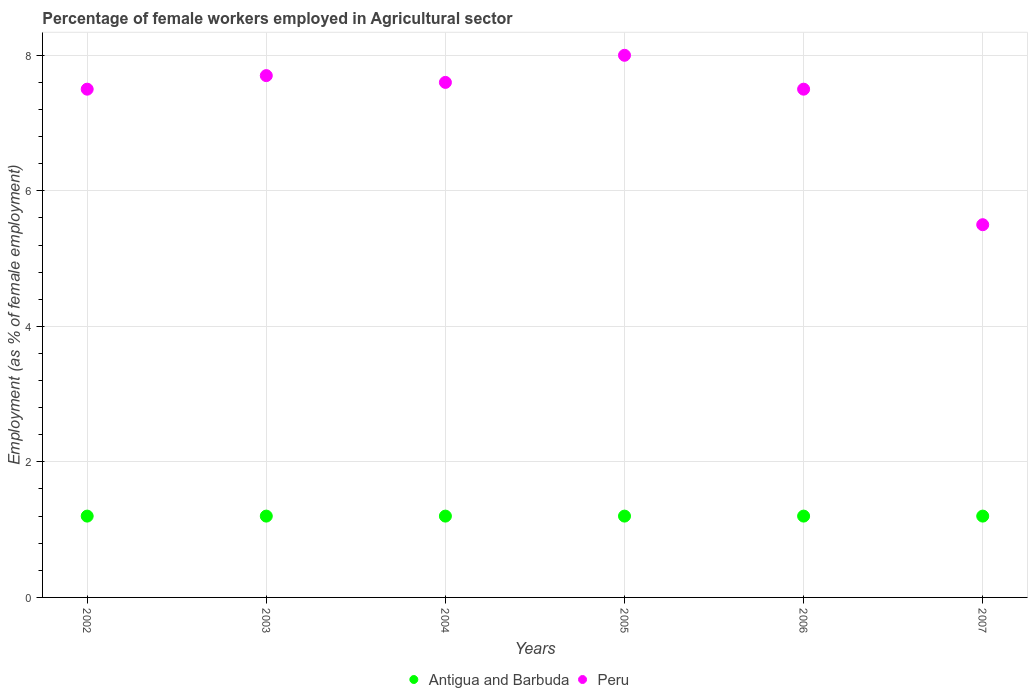How many different coloured dotlines are there?
Your answer should be very brief. 2. What is the percentage of females employed in Agricultural sector in Antigua and Barbuda in 2003?
Give a very brief answer. 1.2. Across all years, what is the maximum percentage of females employed in Agricultural sector in Antigua and Barbuda?
Ensure brevity in your answer.  1.2. In which year was the percentage of females employed in Agricultural sector in Peru minimum?
Offer a terse response. 2007. What is the total percentage of females employed in Agricultural sector in Peru in the graph?
Offer a very short reply. 43.8. What is the difference between the percentage of females employed in Agricultural sector in Antigua and Barbuda in 2002 and that in 2003?
Offer a terse response. 0. What is the difference between the percentage of females employed in Agricultural sector in Antigua and Barbuda in 2003 and the percentage of females employed in Agricultural sector in Peru in 2007?
Your response must be concise. -4.3. What is the average percentage of females employed in Agricultural sector in Peru per year?
Your answer should be very brief. 7.3. In the year 2003, what is the difference between the percentage of females employed in Agricultural sector in Antigua and Barbuda and percentage of females employed in Agricultural sector in Peru?
Ensure brevity in your answer.  -6.5. In how many years, is the percentage of females employed in Agricultural sector in Antigua and Barbuda greater than 6.4 %?
Make the answer very short. 0. What is the ratio of the percentage of females employed in Agricultural sector in Peru in 2005 to that in 2007?
Offer a terse response. 1.45. Is the percentage of females employed in Agricultural sector in Peru in 2003 less than that in 2004?
Offer a terse response. No. What is the difference between the highest and the second highest percentage of females employed in Agricultural sector in Peru?
Make the answer very short. 0.3. What is the difference between the highest and the lowest percentage of females employed in Agricultural sector in Antigua and Barbuda?
Keep it short and to the point. 0. In how many years, is the percentage of females employed in Agricultural sector in Peru greater than the average percentage of females employed in Agricultural sector in Peru taken over all years?
Provide a succinct answer. 5. Are the values on the major ticks of Y-axis written in scientific E-notation?
Offer a very short reply. No. Does the graph contain grids?
Offer a very short reply. Yes. How are the legend labels stacked?
Provide a succinct answer. Horizontal. What is the title of the graph?
Give a very brief answer. Percentage of female workers employed in Agricultural sector. Does "Marshall Islands" appear as one of the legend labels in the graph?
Provide a short and direct response. No. What is the label or title of the X-axis?
Keep it short and to the point. Years. What is the label or title of the Y-axis?
Provide a succinct answer. Employment (as % of female employment). What is the Employment (as % of female employment) of Antigua and Barbuda in 2002?
Ensure brevity in your answer.  1.2. What is the Employment (as % of female employment) in Peru in 2002?
Keep it short and to the point. 7.5. What is the Employment (as % of female employment) of Antigua and Barbuda in 2003?
Give a very brief answer. 1.2. What is the Employment (as % of female employment) of Peru in 2003?
Give a very brief answer. 7.7. What is the Employment (as % of female employment) in Antigua and Barbuda in 2004?
Ensure brevity in your answer.  1.2. What is the Employment (as % of female employment) of Peru in 2004?
Your response must be concise. 7.6. What is the Employment (as % of female employment) of Antigua and Barbuda in 2005?
Your answer should be very brief. 1.2. What is the Employment (as % of female employment) in Peru in 2005?
Give a very brief answer. 8. What is the Employment (as % of female employment) in Antigua and Barbuda in 2006?
Your answer should be very brief. 1.2. What is the Employment (as % of female employment) in Antigua and Barbuda in 2007?
Offer a terse response. 1.2. What is the Employment (as % of female employment) of Peru in 2007?
Make the answer very short. 5.5. Across all years, what is the maximum Employment (as % of female employment) in Antigua and Barbuda?
Offer a terse response. 1.2. Across all years, what is the maximum Employment (as % of female employment) in Peru?
Ensure brevity in your answer.  8. Across all years, what is the minimum Employment (as % of female employment) in Antigua and Barbuda?
Keep it short and to the point. 1.2. What is the total Employment (as % of female employment) of Peru in the graph?
Provide a succinct answer. 43.8. What is the difference between the Employment (as % of female employment) in Antigua and Barbuda in 2002 and that in 2003?
Your response must be concise. 0. What is the difference between the Employment (as % of female employment) of Peru in 2002 and that in 2003?
Provide a succinct answer. -0.2. What is the difference between the Employment (as % of female employment) in Antigua and Barbuda in 2002 and that in 2004?
Give a very brief answer. 0. What is the difference between the Employment (as % of female employment) of Peru in 2002 and that in 2004?
Keep it short and to the point. -0.1. What is the difference between the Employment (as % of female employment) of Antigua and Barbuda in 2002 and that in 2005?
Offer a very short reply. 0. What is the difference between the Employment (as % of female employment) in Peru in 2002 and that in 2005?
Your answer should be very brief. -0.5. What is the difference between the Employment (as % of female employment) of Antigua and Barbuda in 2002 and that in 2006?
Make the answer very short. 0. What is the difference between the Employment (as % of female employment) of Peru in 2002 and that in 2007?
Your response must be concise. 2. What is the difference between the Employment (as % of female employment) in Antigua and Barbuda in 2003 and that in 2004?
Keep it short and to the point. 0. What is the difference between the Employment (as % of female employment) of Peru in 2003 and that in 2005?
Provide a succinct answer. -0.3. What is the difference between the Employment (as % of female employment) in Antigua and Barbuda in 2003 and that in 2007?
Your response must be concise. 0. What is the difference between the Employment (as % of female employment) in Antigua and Barbuda in 2004 and that in 2006?
Give a very brief answer. 0. What is the difference between the Employment (as % of female employment) in Antigua and Barbuda in 2005 and that in 2006?
Make the answer very short. 0. What is the difference between the Employment (as % of female employment) in Peru in 2005 and that in 2007?
Offer a very short reply. 2.5. What is the difference between the Employment (as % of female employment) in Antigua and Barbuda in 2002 and the Employment (as % of female employment) in Peru in 2004?
Keep it short and to the point. -6.4. What is the difference between the Employment (as % of female employment) of Antigua and Barbuda in 2002 and the Employment (as % of female employment) of Peru in 2005?
Your answer should be very brief. -6.8. What is the difference between the Employment (as % of female employment) of Antigua and Barbuda in 2002 and the Employment (as % of female employment) of Peru in 2006?
Provide a short and direct response. -6.3. What is the difference between the Employment (as % of female employment) in Antigua and Barbuda in 2002 and the Employment (as % of female employment) in Peru in 2007?
Provide a succinct answer. -4.3. What is the difference between the Employment (as % of female employment) of Antigua and Barbuda in 2003 and the Employment (as % of female employment) of Peru in 2007?
Your answer should be very brief. -4.3. What is the difference between the Employment (as % of female employment) in Antigua and Barbuda in 2004 and the Employment (as % of female employment) in Peru in 2005?
Ensure brevity in your answer.  -6.8. What is the difference between the Employment (as % of female employment) of Antigua and Barbuda in 2004 and the Employment (as % of female employment) of Peru in 2006?
Keep it short and to the point. -6.3. What is the difference between the Employment (as % of female employment) in Antigua and Barbuda in 2004 and the Employment (as % of female employment) in Peru in 2007?
Make the answer very short. -4.3. In the year 2003, what is the difference between the Employment (as % of female employment) in Antigua and Barbuda and Employment (as % of female employment) in Peru?
Your response must be concise. -6.5. In the year 2006, what is the difference between the Employment (as % of female employment) in Antigua and Barbuda and Employment (as % of female employment) in Peru?
Your response must be concise. -6.3. In the year 2007, what is the difference between the Employment (as % of female employment) of Antigua and Barbuda and Employment (as % of female employment) of Peru?
Offer a very short reply. -4.3. What is the ratio of the Employment (as % of female employment) of Peru in 2002 to that in 2003?
Your answer should be very brief. 0.97. What is the ratio of the Employment (as % of female employment) in Antigua and Barbuda in 2002 to that in 2004?
Offer a very short reply. 1. What is the ratio of the Employment (as % of female employment) of Antigua and Barbuda in 2002 to that in 2006?
Your response must be concise. 1. What is the ratio of the Employment (as % of female employment) in Peru in 2002 to that in 2007?
Your response must be concise. 1.36. What is the ratio of the Employment (as % of female employment) in Antigua and Barbuda in 2003 to that in 2004?
Your answer should be compact. 1. What is the ratio of the Employment (as % of female employment) in Peru in 2003 to that in 2004?
Make the answer very short. 1.01. What is the ratio of the Employment (as % of female employment) in Peru in 2003 to that in 2005?
Offer a terse response. 0.96. What is the ratio of the Employment (as % of female employment) in Antigua and Barbuda in 2003 to that in 2006?
Provide a short and direct response. 1. What is the ratio of the Employment (as % of female employment) in Peru in 2003 to that in 2006?
Ensure brevity in your answer.  1.03. What is the ratio of the Employment (as % of female employment) of Peru in 2003 to that in 2007?
Keep it short and to the point. 1.4. What is the ratio of the Employment (as % of female employment) of Peru in 2004 to that in 2005?
Keep it short and to the point. 0.95. What is the ratio of the Employment (as % of female employment) in Antigua and Barbuda in 2004 to that in 2006?
Provide a succinct answer. 1. What is the ratio of the Employment (as % of female employment) in Peru in 2004 to that in 2006?
Your response must be concise. 1.01. What is the ratio of the Employment (as % of female employment) of Peru in 2004 to that in 2007?
Your answer should be very brief. 1.38. What is the ratio of the Employment (as % of female employment) of Antigua and Barbuda in 2005 to that in 2006?
Provide a succinct answer. 1. What is the ratio of the Employment (as % of female employment) in Peru in 2005 to that in 2006?
Your response must be concise. 1.07. What is the ratio of the Employment (as % of female employment) of Antigua and Barbuda in 2005 to that in 2007?
Keep it short and to the point. 1. What is the ratio of the Employment (as % of female employment) of Peru in 2005 to that in 2007?
Provide a short and direct response. 1.45. What is the ratio of the Employment (as % of female employment) in Antigua and Barbuda in 2006 to that in 2007?
Make the answer very short. 1. What is the ratio of the Employment (as % of female employment) of Peru in 2006 to that in 2007?
Your answer should be compact. 1.36. What is the difference between the highest and the second highest Employment (as % of female employment) of Peru?
Offer a very short reply. 0.3. What is the difference between the highest and the lowest Employment (as % of female employment) of Antigua and Barbuda?
Provide a short and direct response. 0. 